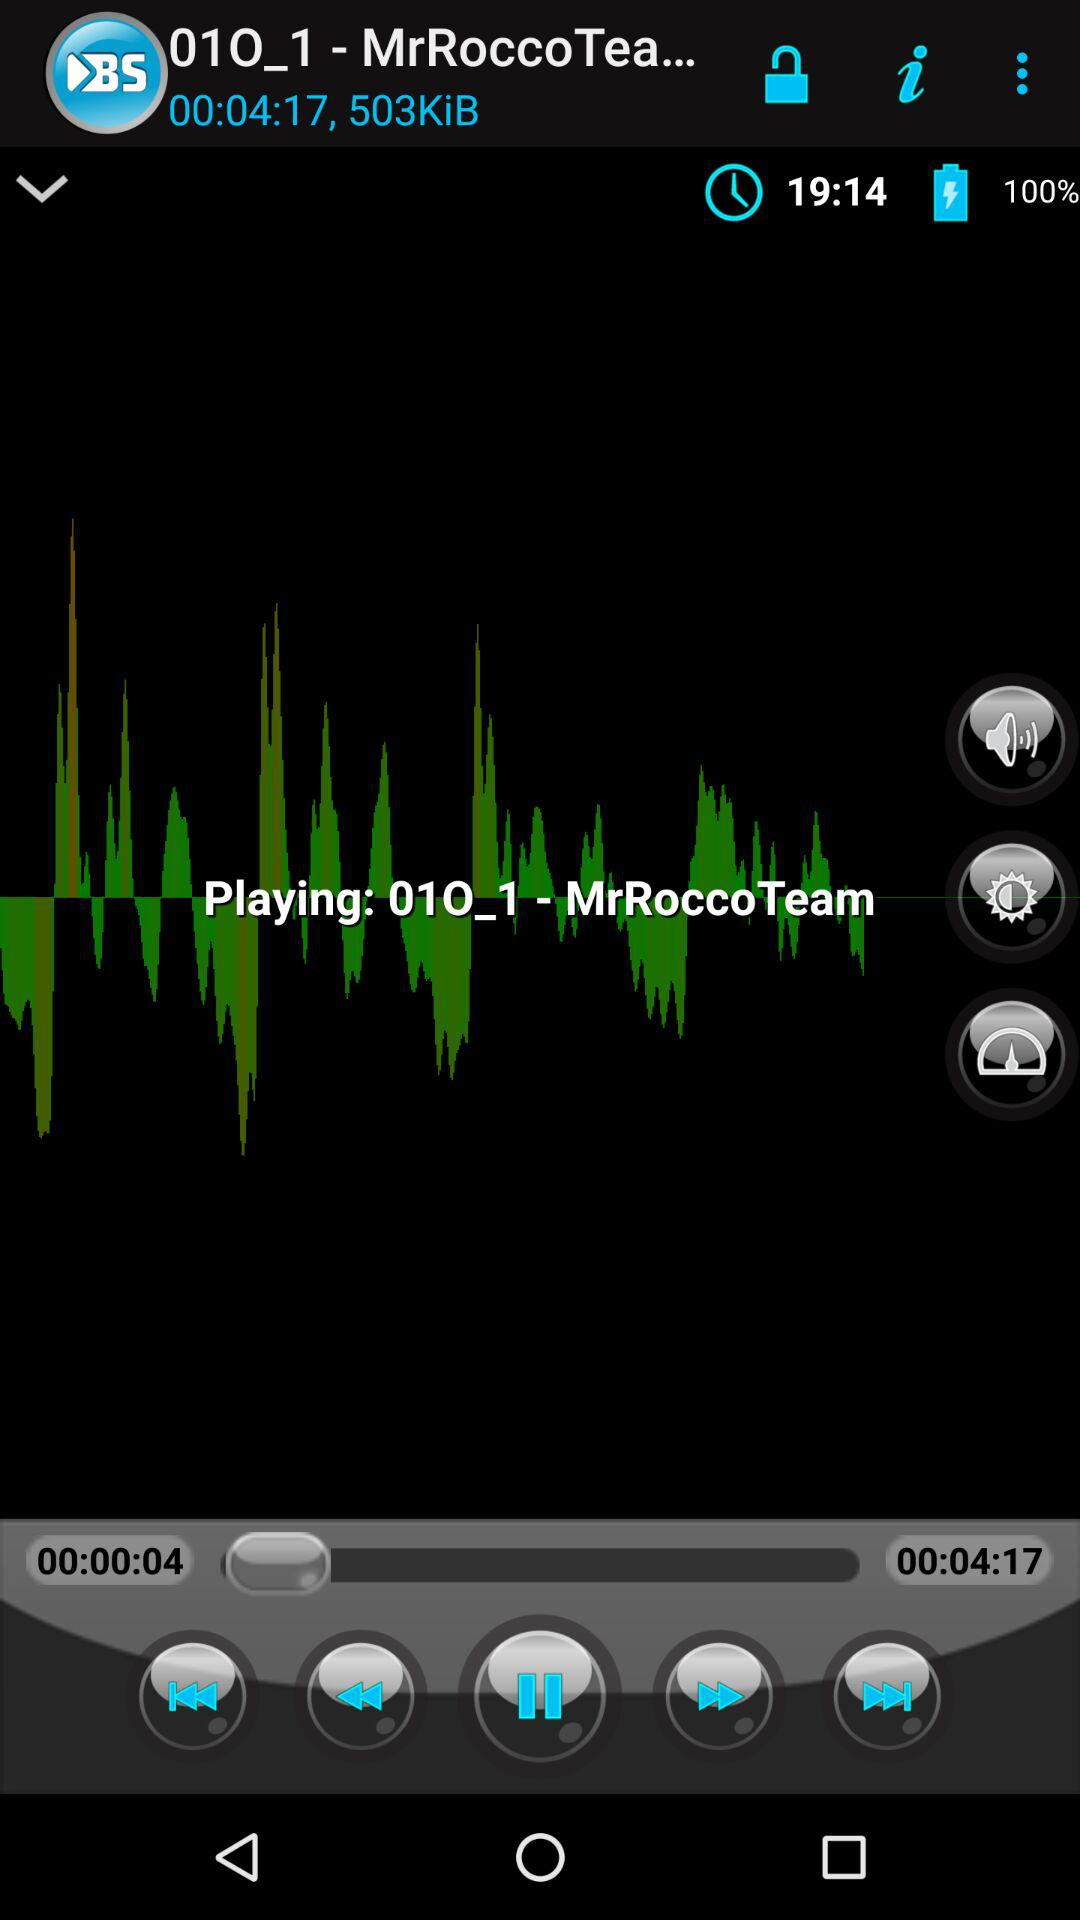What is the time? The time is 19:14. 